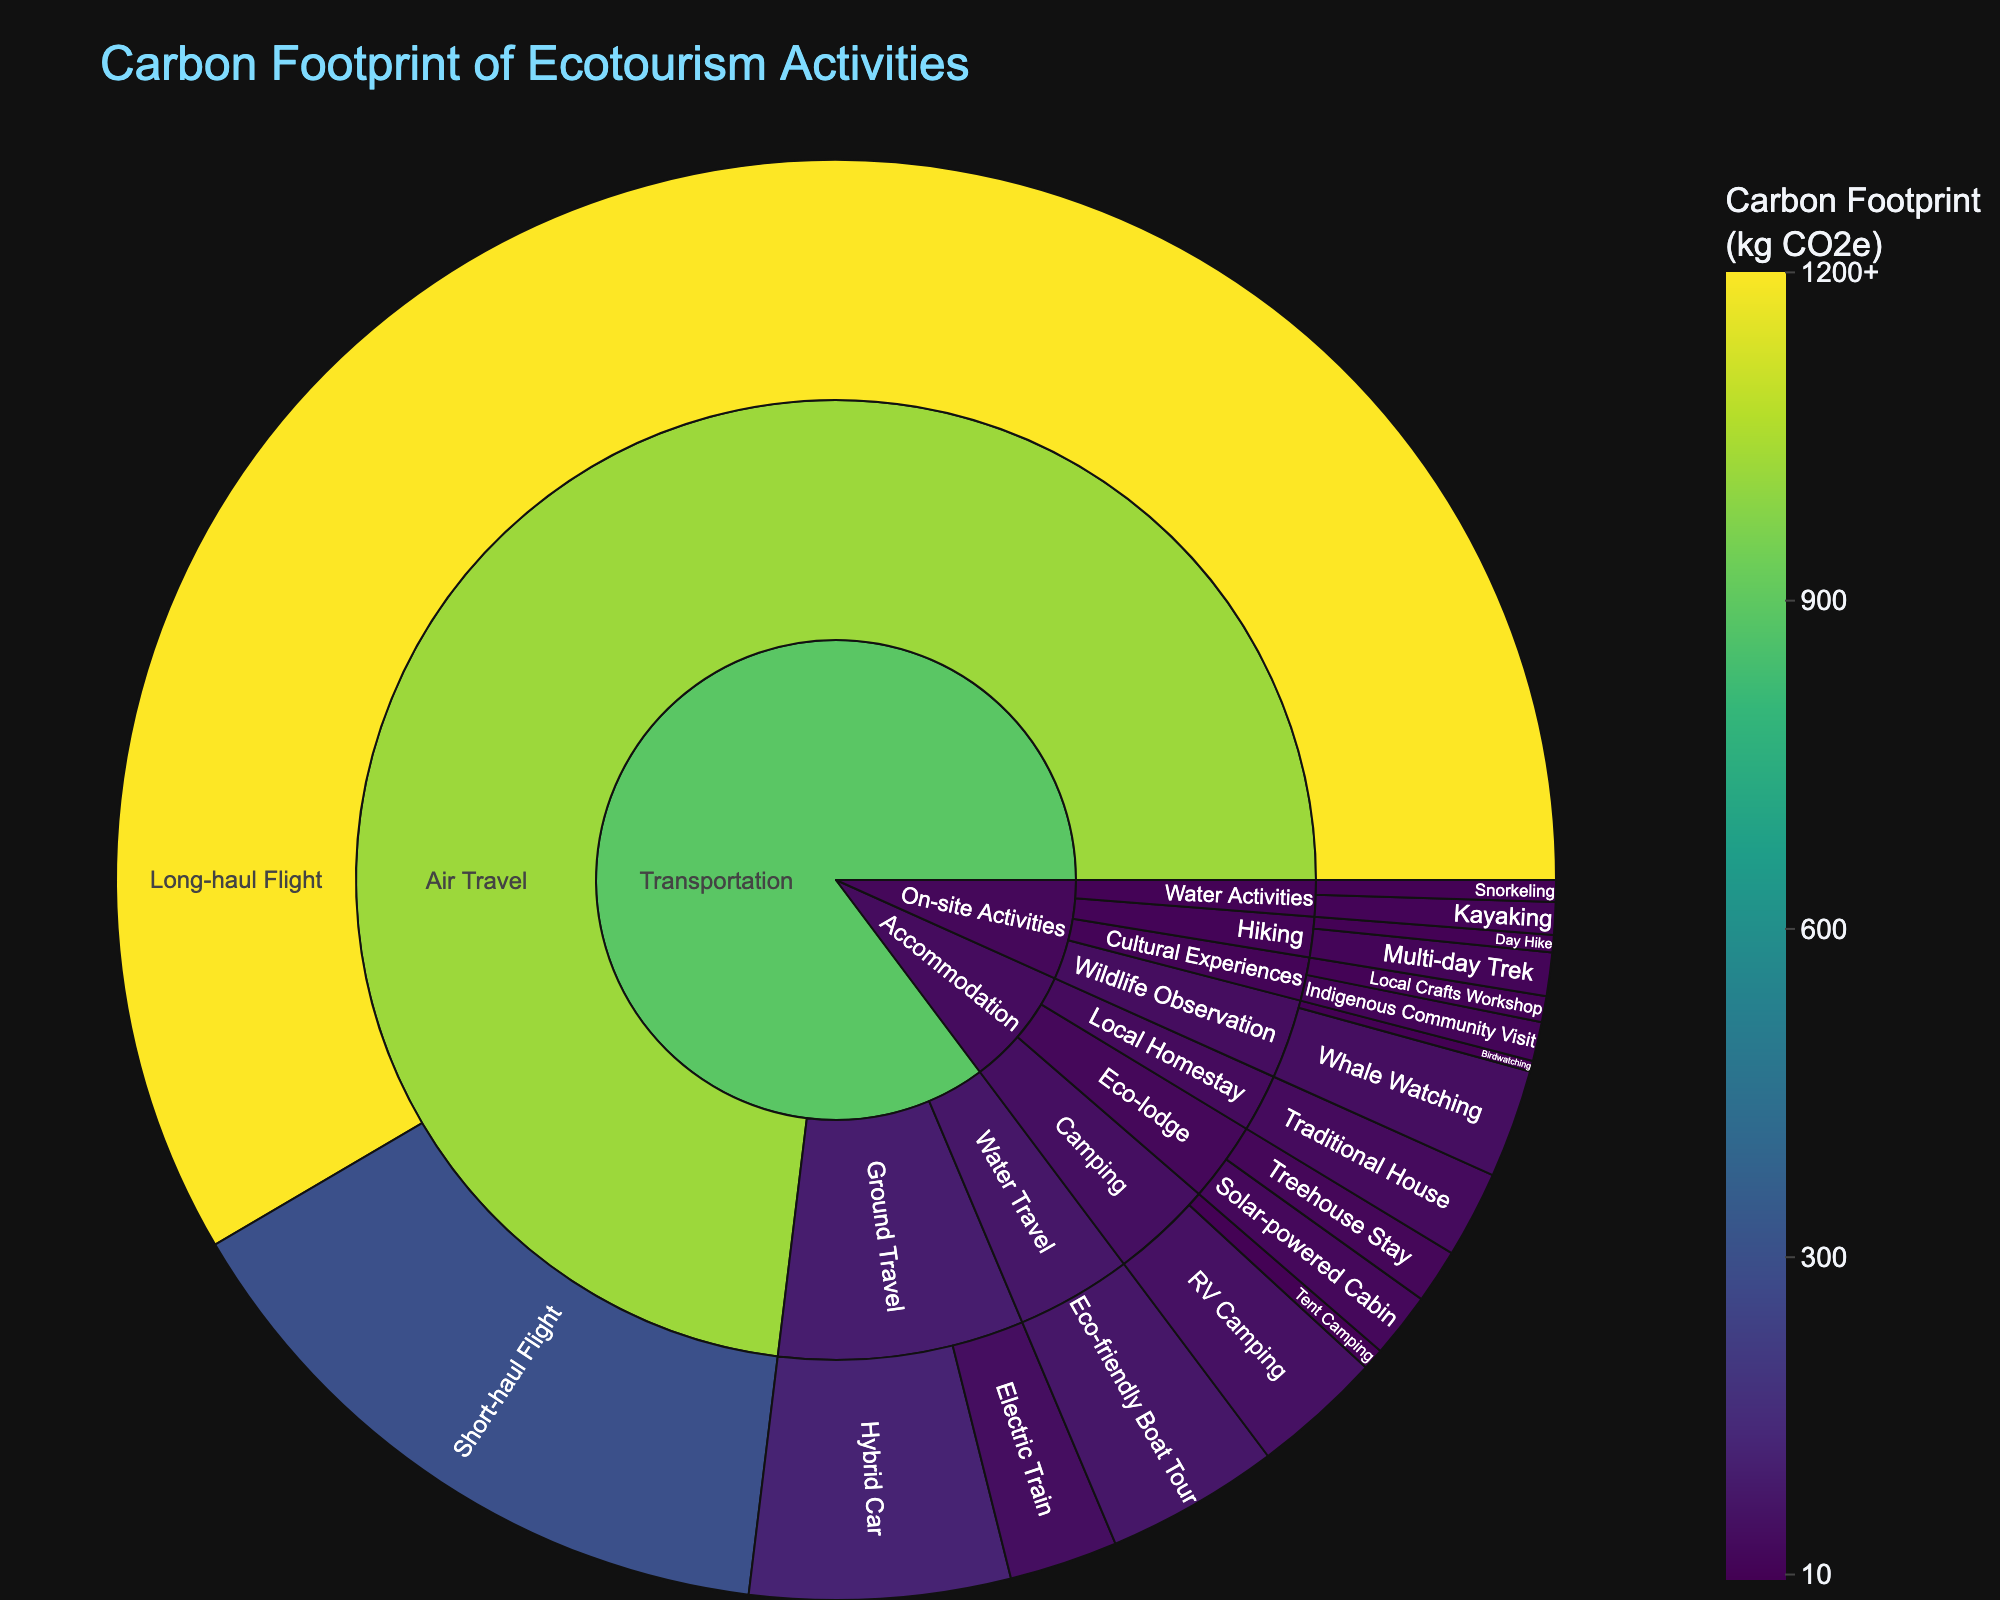How many main categories are shown in the Sunburst Plot? The Sunburst Plot shows three main categories: Transportation, Accommodation, and On-site Activities. These are the first divisions of the plot from the center.
Answer: 3 Which transportation method has the highest carbon footprint per activity? By looking at the Sunburst Plot, we can see that 'Long-haul Flight' under 'Air Travel' in the 'Transportation' category has the highest carbon footprint per activity, with a value of 1200 kg CO2e.
Answer: Long-haul Flight What is the total carbon footprint of air travel as shown in the plot? The total carbon footprint of air travel is the sum of Long-haul Flight and Short-haul Flight. This is 1200 kg CO2e + 300 kg CO2e = 1500 kg CO2e.
Answer: 1500 kg CO2e Which accommodation type has the lowest carbon footprint per activity? The accommodation type with the lowest carbon footprint per activity is 'Tent Camping' under 'Camping' in the 'Accommodation' category, with a value of 10 kg CO2e.
Answer: Tent Camping Compare the carbon footprint of Electric Train and Hybrid Car in ground travel. Which one is higher and by how much? The carbon footprint of Electric Train is 50 kg CO2e and that of Hybrid Car is 120 kg CO2e. Hybrid Car has a higher carbon footprint by 120 - 50 = 70 kg CO2e.
Answer: Hybrid Car, 70 kg CO2e Among on-site activities, which subcategory has activities with the highest and lowest carbon footprints? The subcategory 'Wildlife Observation' contains activities with the highest (Whale Watching at 50 kg CO2e) and lowest (Birdwatching at 5 kg CO2e) carbon footprints among on-site activities.
Answer: Wildlife Observation What is the combined carbon footprint of all on-site activities listed in the plot? Summing the carbon footprints of all on-site activities: Birdwatching (5) + Whale Watching (50) + Day Hike (8) + Multi-day Trek (20) + Kayaking (15) + Snorkeling (10) + Local Crafts Workshop (12) + Indigenous Community Visit (18) = 138 kg CO2e.
Answer: 138 kg CO2e Which type of water travel has a lower carbon footprint and what is the value? The Sunburst Plot shows only one type of water travel, which is 'Eco-friendly Boat Tour' under 'Water Travel' in the 'Transportation' category, and it has a carbon footprint of 80 kg CO2e.
Answer: Eco-friendly Boat Tour, 80 kg CO2e What is the carbon footprint difference between RV Camping and Treehouse Stay? RV Camping has a carbon footprint of 60 kg CO2e, and Treehouse Stay has 25 kg CO2e. The difference is 60 - 25 = 35 kg CO2e.
Answer: 35 kg CO2e Which subcategory in on-site activities has a higher total carbon footprint: Water Activities or Cultural Experiences? The total for Water Activities is Kayaking (15) + Snorkeling (10) = 25 kg CO2e. The total for Cultural Experiences is Local Crafts Workshop (12) + Indigenous Community Visit (18) = 30 kg CO2e. Therefore, Cultural Experiences has a higher total carbon footprint.
Answer: Cultural Experiences 